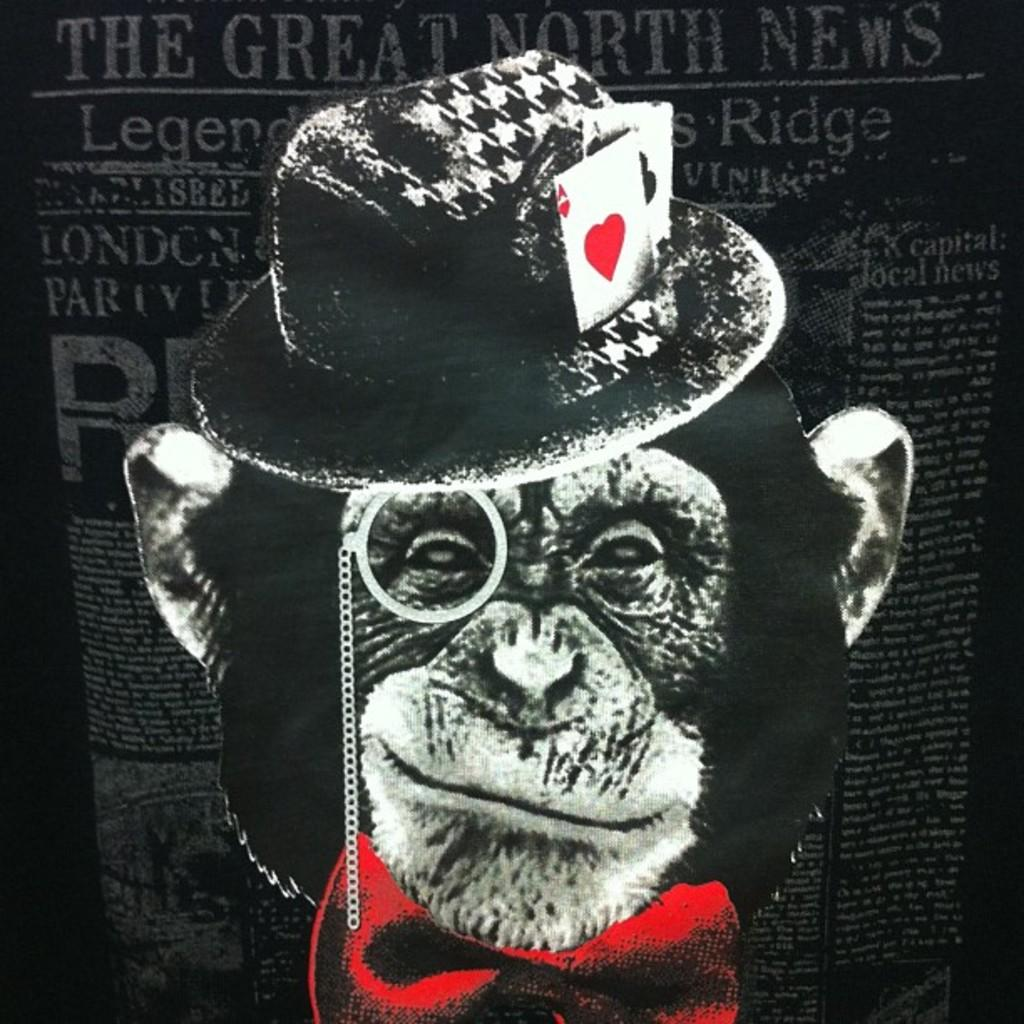What is featured on the poster in the image? The poster contains text and an image of a monkey. What is the monkey in the image wearing? The monkey in the image is wearing a hat. What type of straw is the monkey using to drink in the image? There is no straw present in the image; the monkey is not depicted drinking anything. 